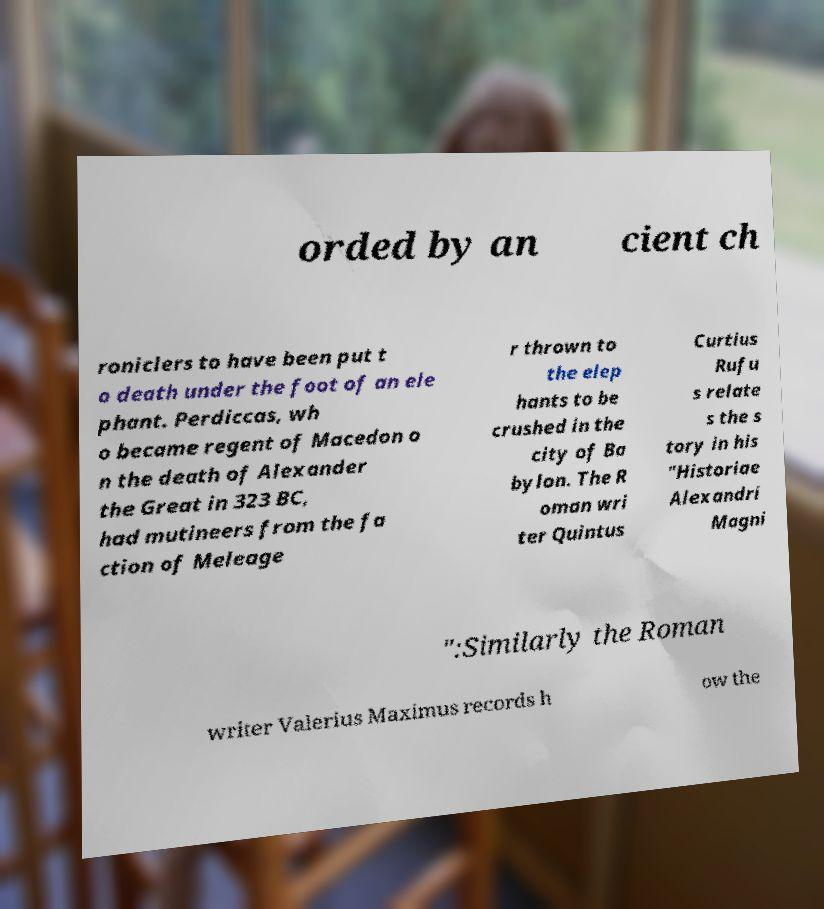Can you read and provide the text displayed in the image?This photo seems to have some interesting text. Can you extract and type it out for me? orded by an cient ch roniclers to have been put t o death under the foot of an ele phant. Perdiccas, wh o became regent of Macedon o n the death of Alexander the Great in 323 BC, had mutineers from the fa ction of Meleage r thrown to the elep hants to be crushed in the city of Ba bylon. The R oman wri ter Quintus Curtius Rufu s relate s the s tory in his "Historiae Alexandri Magni ":Similarly the Roman writer Valerius Maximus records h ow the 